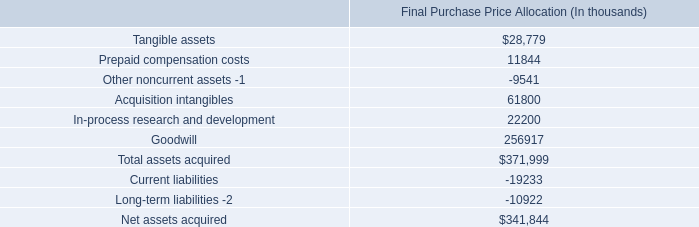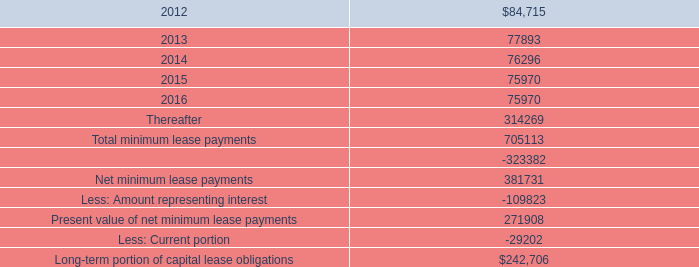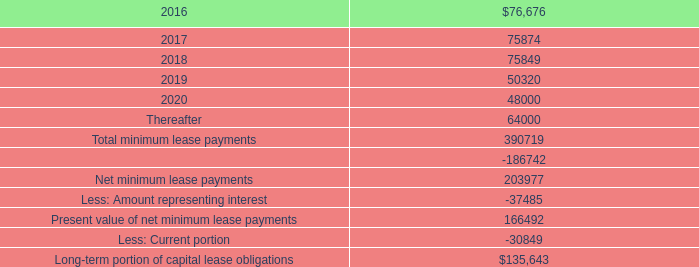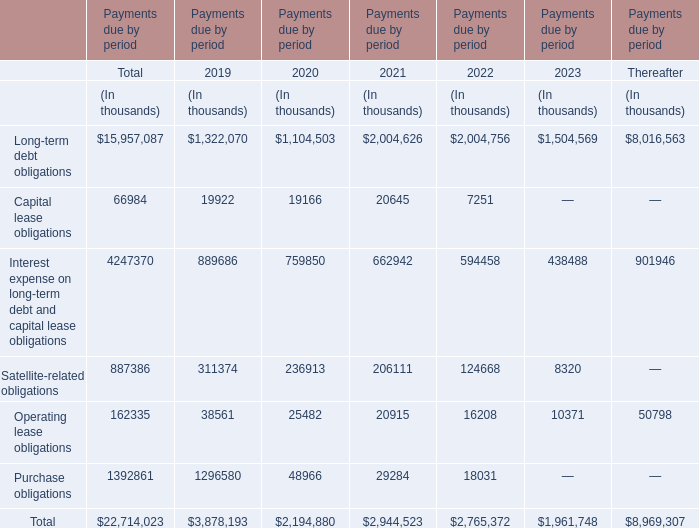What's the total value of all Payments due by period that are smaller than 900000 in 2019? (in thousand) 
Computations: (((19922 + 889686) + 311374) + 38561)
Answer: 1259543.0. 